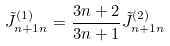<formula> <loc_0><loc_0><loc_500><loc_500>\tilde { J } _ { n + 1 n } ^ { ( 1 ) } = \frac { 3 n + 2 } { 3 n + 1 } \tilde { J } _ { n + 1 n } ^ { ( 2 ) }</formula> 